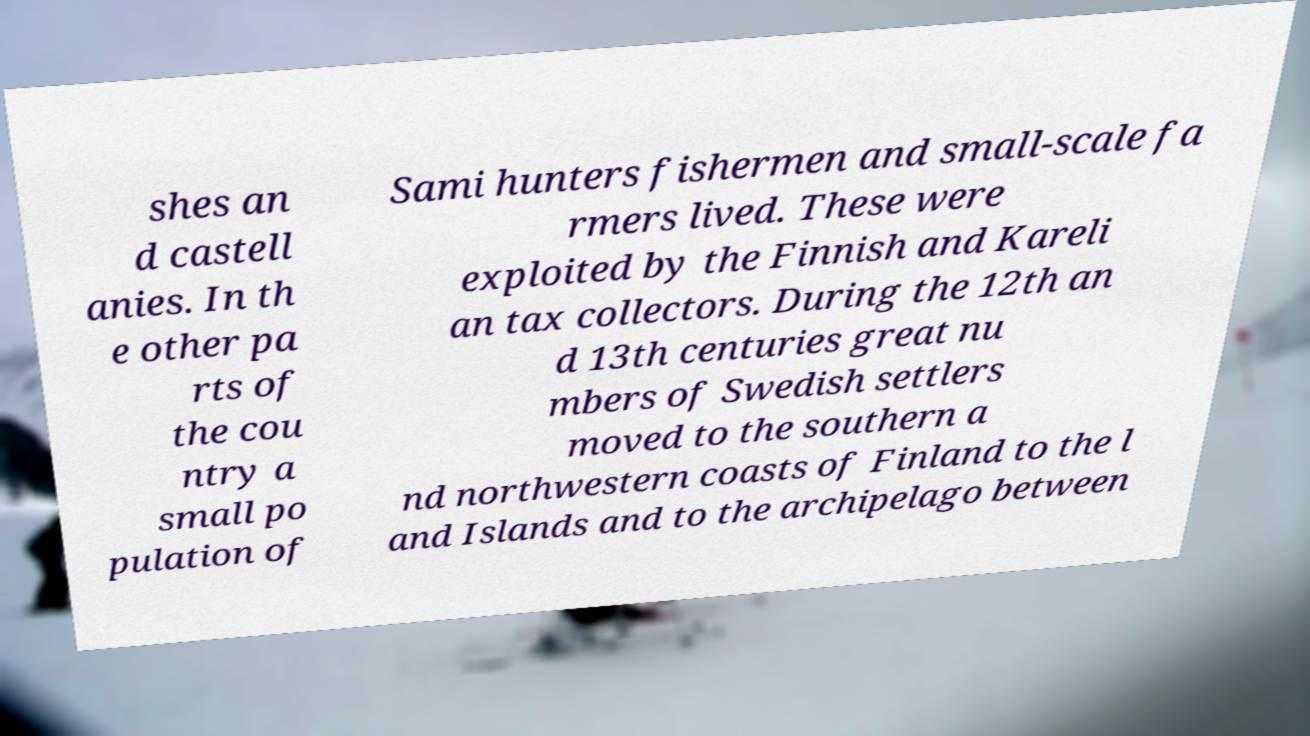Could you assist in decoding the text presented in this image and type it out clearly? shes an d castell anies. In th e other pa rts of the cou ntry a small po pulation of Sami hunters fishermen and small-scale fa rmers lived. These were exploited by the Finnish and Kareli an tax collectors. During the 12th an d 13th centuries great nu mbers of Swedish settlers moved to the southern a nd northwestern coasts of Finland to the l and Islands and to the archipelago between 